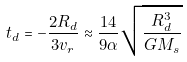Convert formula to latex. <formula><loc_0><loc_0><loc_500><loc_500>t _ { d } = - \frac { 2 R _ { d } } { 3 v _ { r } } \approx \frac { 1 4 } { 9 \alpha } \sqrt { \frac { R _ { d } ^ { 3 } } { G M _ { s } } }</formula> 